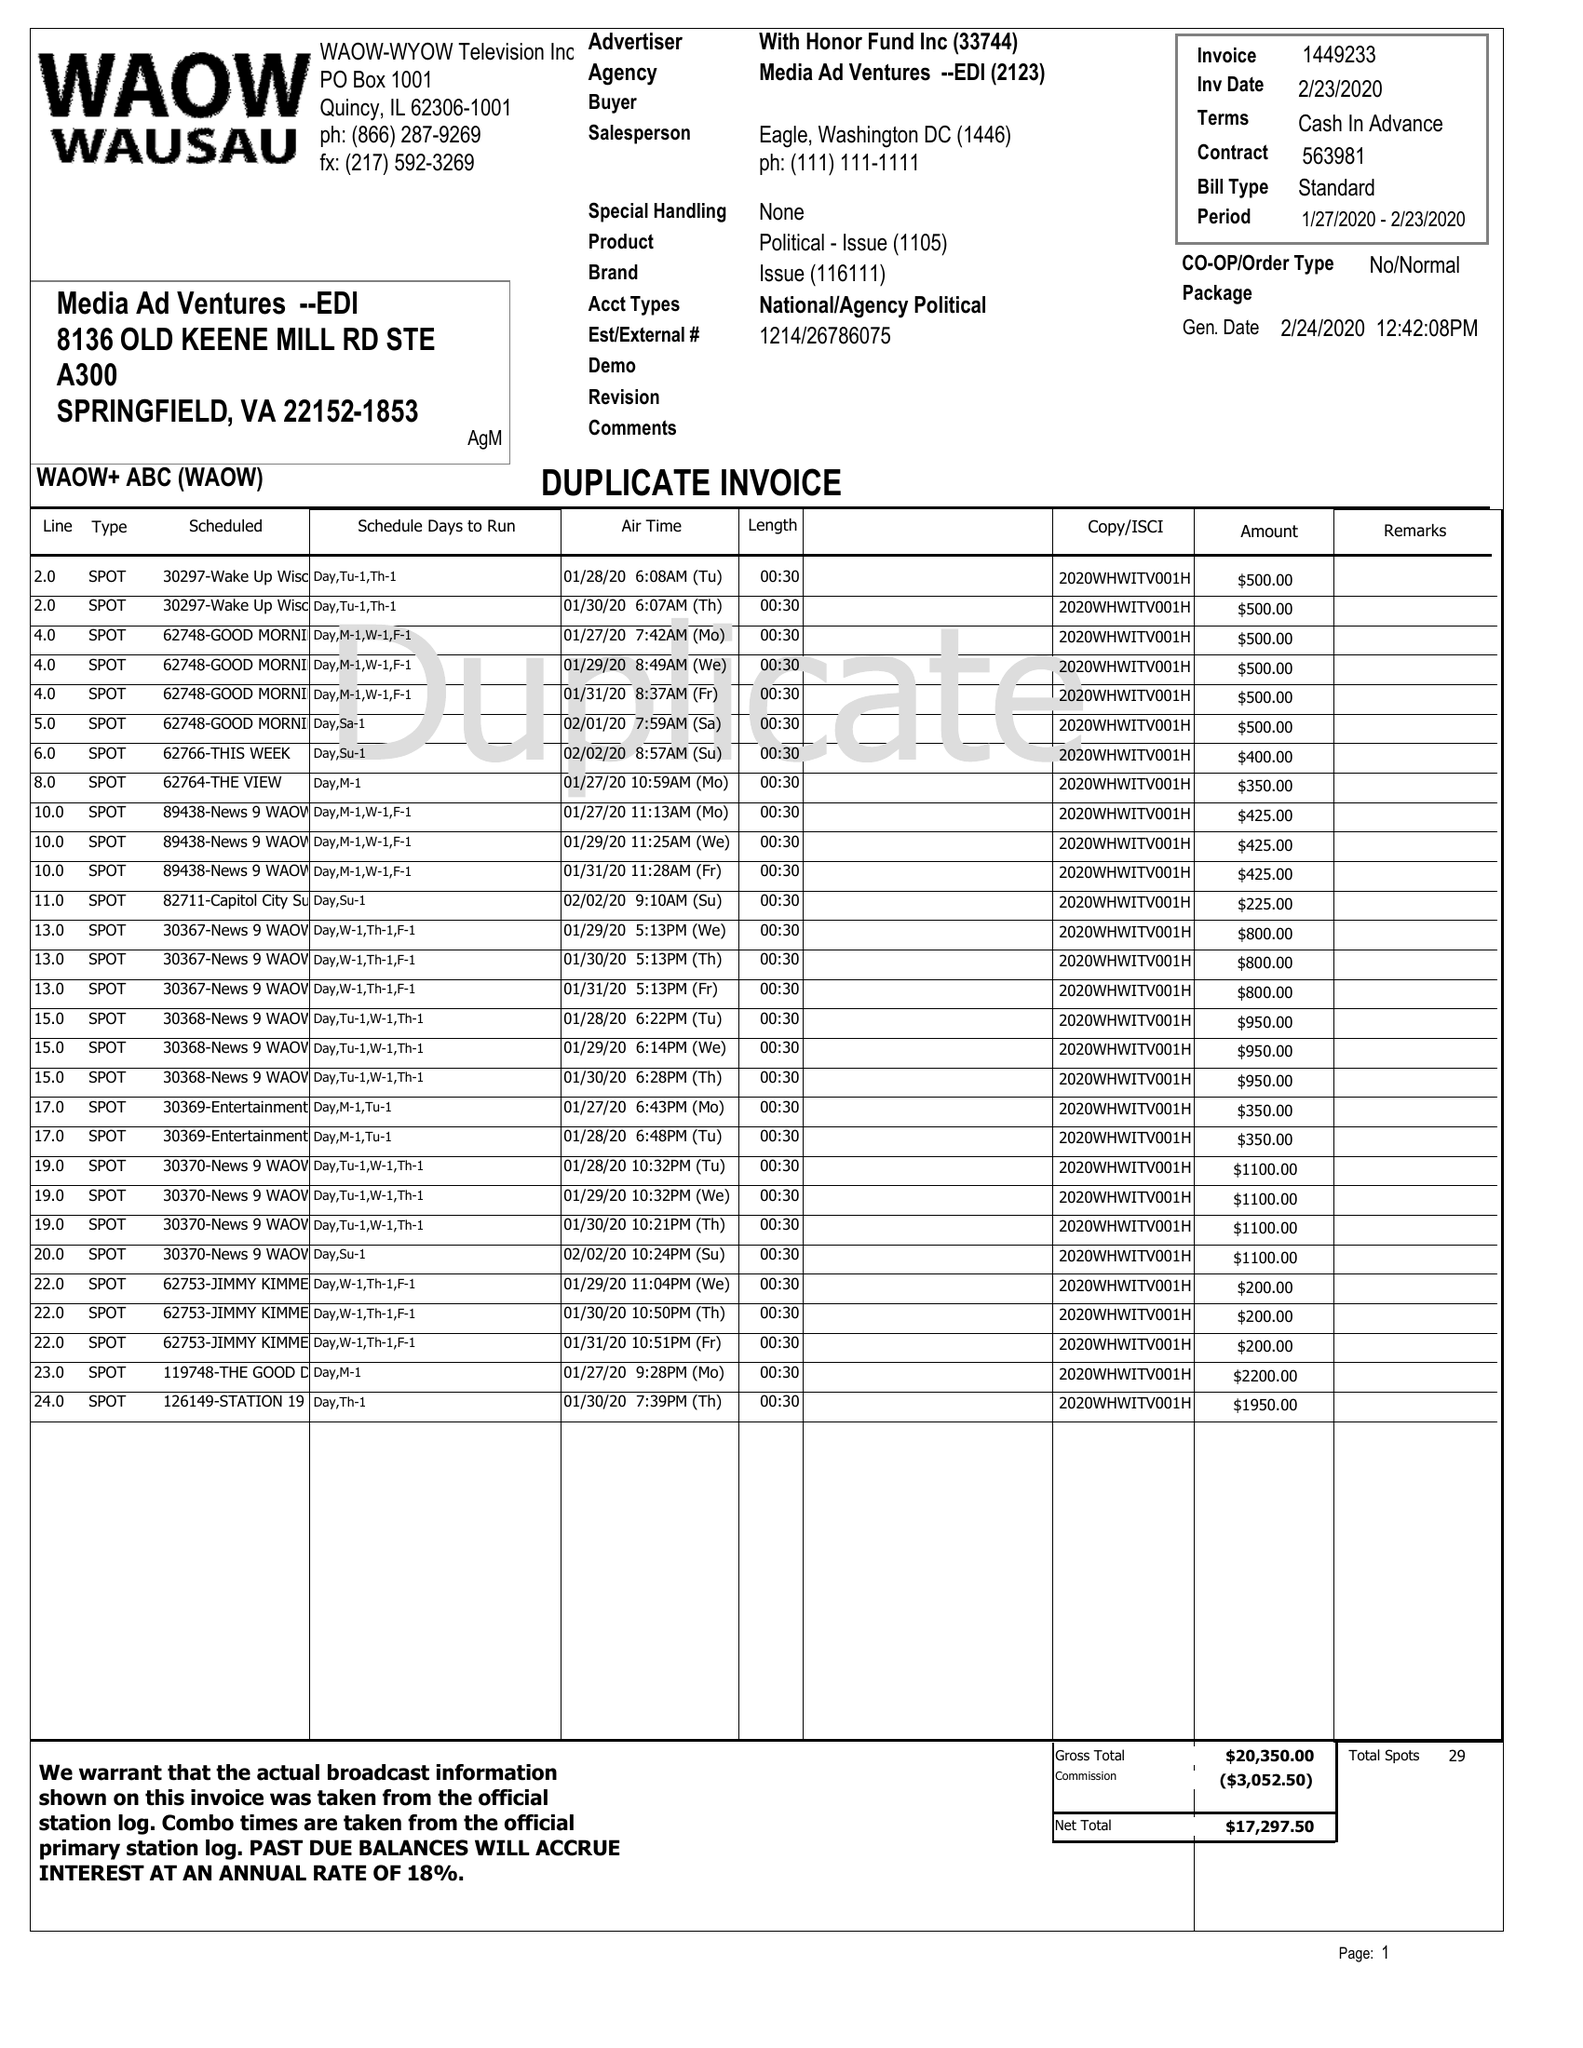What is the value for the contract_num?
Answer the question using a single word or phrase. 1449233 